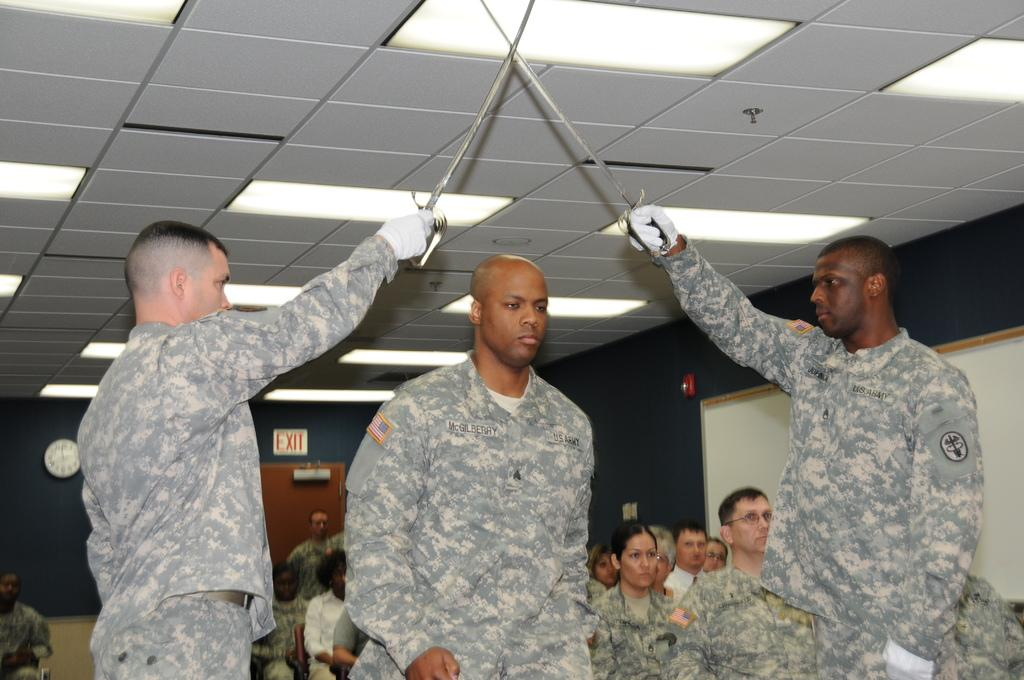Who or what can be seen in the image? There are people in the image. What is located in the background of the image? There is a wall with text in the background of the image. What can be seen at the top of the image? There are lights visible at the top of the image. What type of toys can be seen being played with by the people in the image? There are no toys visible in the image; it only shows people and a wall with text in the background. 